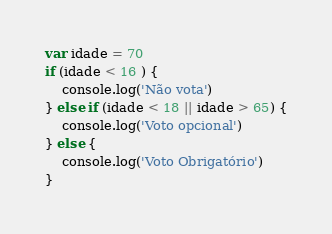<code> <loc_0><loc_0><loc_500><loc_500><_JavaScript_>var idade = 70
if (idade < 16 ) {
    console.log('Não vota')
} else if (idade < 18 || idade > 65) {
    console.log('Voto opcional')
} else {
    console.log('Voto Obrigatório')
}</code> 